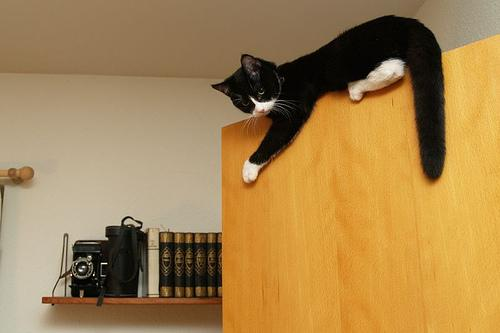What old device can be seen on the left end of the shelf?

Choices:
A) camera
B) television
C) pager
D) phone camera 